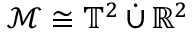Convert formula to latex. <formula><loc_0><loc_0><loc_500><loc_500>\mathcal { M } \cong \mathbb { T } ^ { 2 } \, \dot { \cup } \, \mathbb { R } ^ { 2 }</formula> 